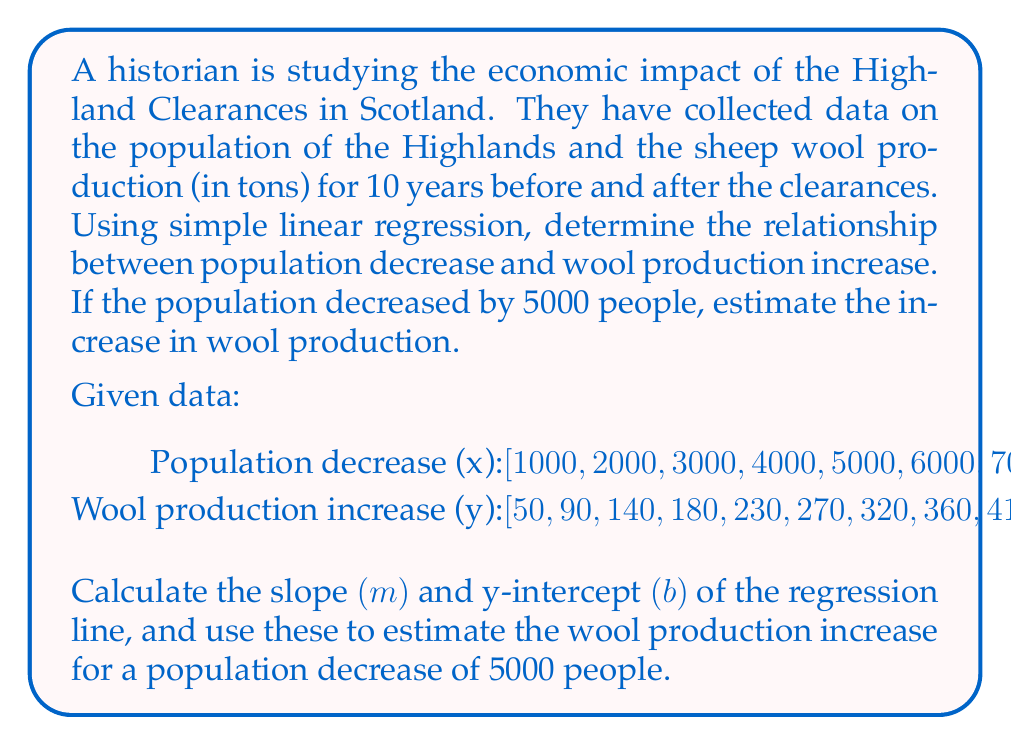Solve this math problem. To solve this problem, we'll use the simple linear regression formula:

$$ y = mx + b $$

Where m is the slope and b is the y-intercept.

Step 1: Calculate the means of x and y.
$$ \bar{x} = \frac{\sum x_i}{n} = \frac{55000}{10} = 5500 $$
$$ \bar{y} = \frac{\sum y_i}{n} = \frac{2500}{10} = 250 $$

Step 2: Calculate the slope (m) using the formula:
$$ m = \frac{\sum (x_i - \bar{x})(y_i - \bar{y})}{\sum (x_i - \bar{x})^2} $$

Calculate the numerator and denominator separately:
Numerator: 8,250,000
Denominator: 82,500,000

$$ m = \frac{8,250,000}{82,500,000} = 0.1 $$

Step 3: Calculate the y-intercept (b) using the formula:
$$ b = \bar{y} - m\bar{x} $$
$$ b = 250 - 0.1(5500) = -300 $$

Step 4: Write the regression equation:
$$ y = 0.1x - 300 $$

Step 5: Estimate the wool production increase for a population decrease of 5000 people:
$$ y = 0.1(5000) - 300 = 200 $$

Therefore, for a population decrease of 5000 people, the estimated increase in wool production is 200 tons.
Answer: The regression equation is $y = 0.1x - 300$, where x is the population decrease and y is the wool production increase. For a population decrease of 5000 people, the estimated increase in wool production is 200 tons. 